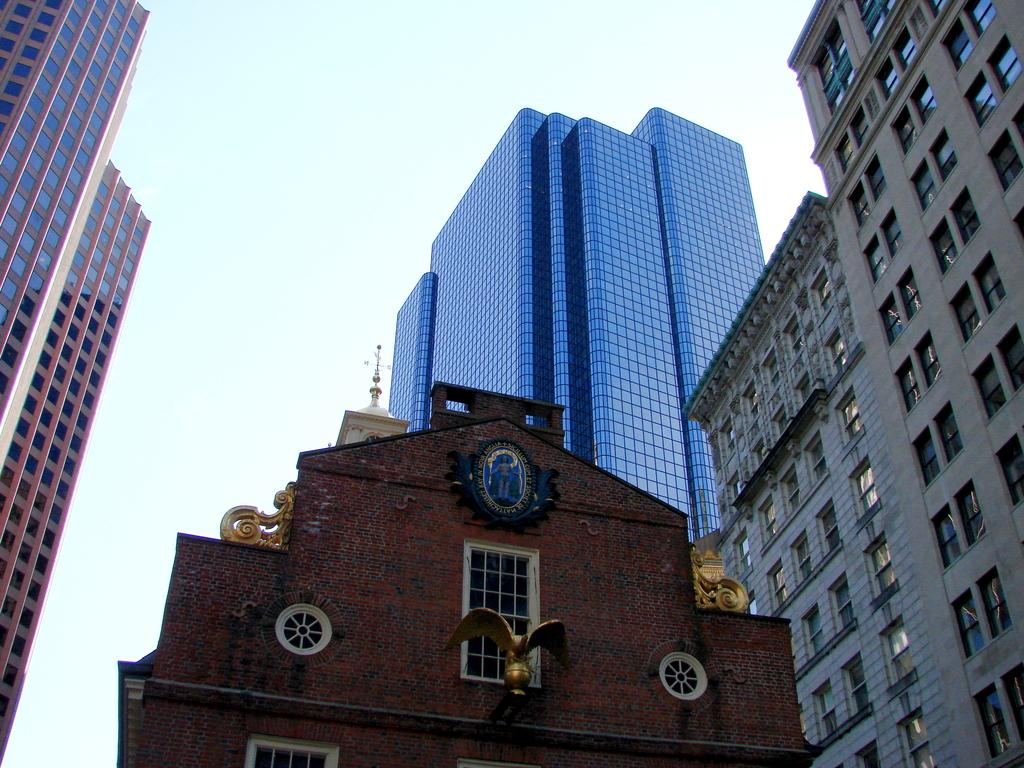What type of structures can be seen in the image? There are buildings in the image. What part of the natural environment is visible in the image? The sky is visible in the image. What type of sign can be seen hanging from the buildings in the image? There is no sign visible in the image; only buildings and the sky are present. What type of zephyr is blowing through the hall in the image? There is no hall or zephyr present in the image. 